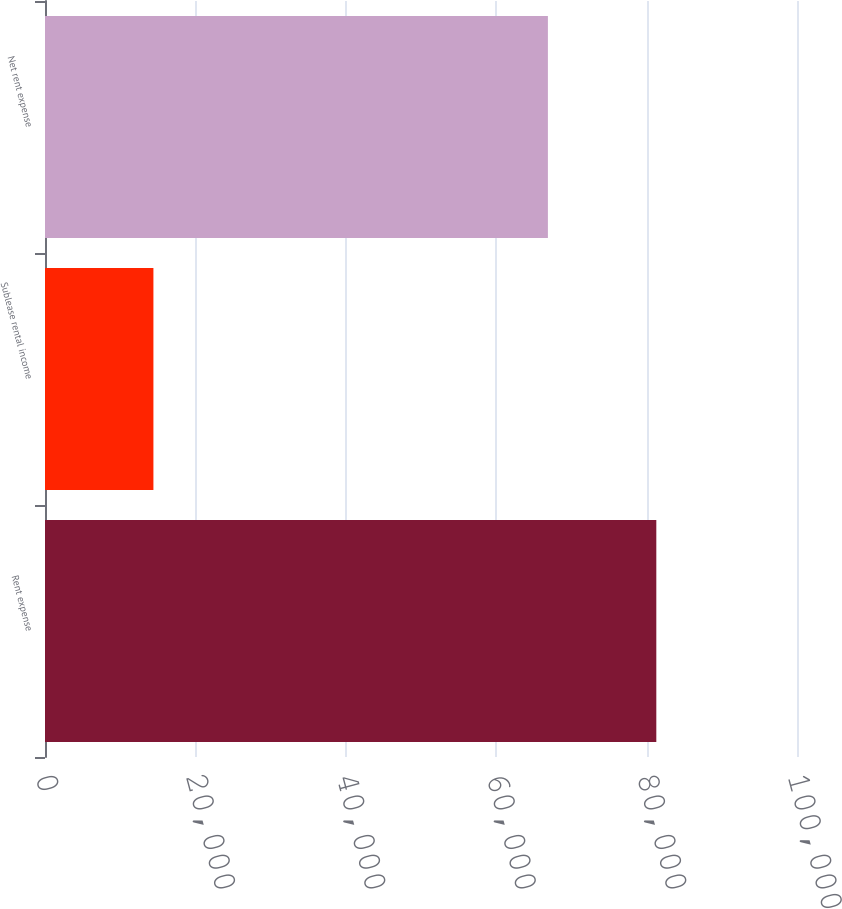Convert chart. <chart><loc_0><loc_0><loc_500><loc_500><bar_chart><fcel>Rent expense<fcel>Sublease rental income<fcel>Net rent expense<nl><fcel>81292<fcel>14417<fcel>66875<nl></chart> 